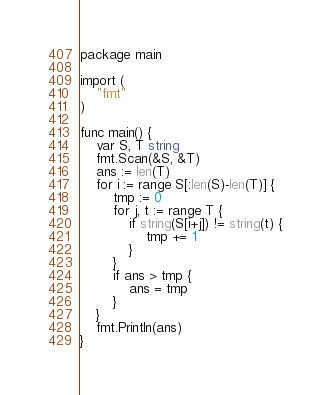<code> <loc_0><loc_0><loc_500><loc_500><_Go_>package main

import (
	"fmt"
)

func main() {
	var S, T string
	fmt.Scan(&S, &T)
	ans := len(T)
	for i := range S[:len(S)-len(T)] {
		tmp := 0
		for j, t := range T {
			if string(S[i+j]) != string(t) {
				tmp += 1
			}
		}
		if ans > tmp {
			ans = tmp
		}
	}
	fmt.Println(ans)
}
</code> 